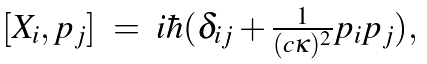<formula> <loc_0><loc_0><loc_500><loc_500>\begin{array} { r c l } [ X _ { i } , p _ { j } ] & = & i \hbar { ( } \delta _ { i j } + \frac { 1 } { ( c \kappa ) ^ { 2 } } p _ { i } p _ { j } ) , \end{array}</formula> 